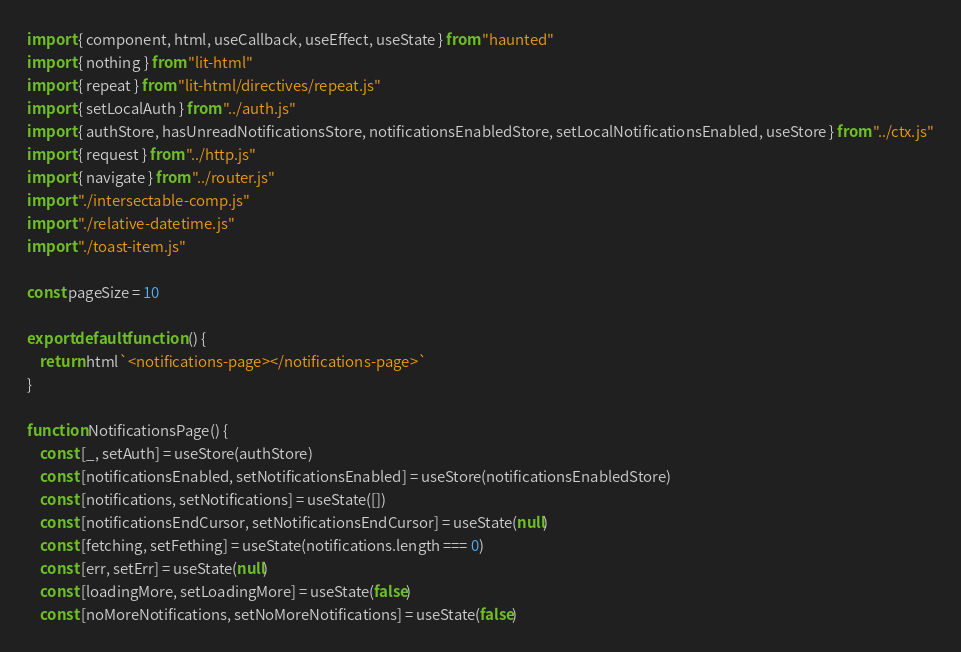<code> <loc_0><loc_0><loc_500><loc_500><_JavaScript_>import { component, html, useCallback, useEffect, useState } from "haunted"
import { nothing } from "lit-html"
import { repeat } from "lit-html/directives/repeat.js"
import { setLocalAuth } from "../auth.js"
import { authStore, hasUnreadNotificationsStore, notificationsEnabledStore, setLocalNotificationsEnabled, useStore } from "../ctx.js"
import { request } from "../http.js"
import { navigate } from "../router.js"
import "./intersectable-comp.js"
import "./relative-datetime.js"
import "./toast-item.js"

const pageSize = 10

export default function () {
    return html`<notifications-page></notifications-page>`
}

function NotificationsPage() {
    const [_, setAuth] = useStore(authStore)
    const [notificationsEnabled, setNotificationsEnabled] = useStore(notificationsEnabledStore)
    const [notifications, setNotifications] = useState([])
    const [notificationsEndCursor, setNotificationsEndCursor] = useState(null)
    const [fetching, setFething] = useState(notifications.length === 0)
    const [err, setErr] = useState(null)
    const [loadingMore, setLoadingMore] = useState(false)
    const [noMoreNotifications, setNoMoreNotifications] = useState(false)</code> 